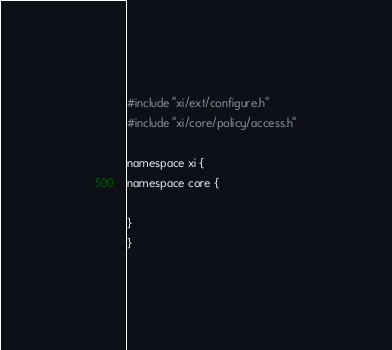Convert code to text. <code><loc_0><loc_0><loc_500><loc_500><_C_>
#include "xi/ext/configure.h"
#include "xi/core/policy/access.h"

namespace xi {
namespace core {

}
}
</code> 